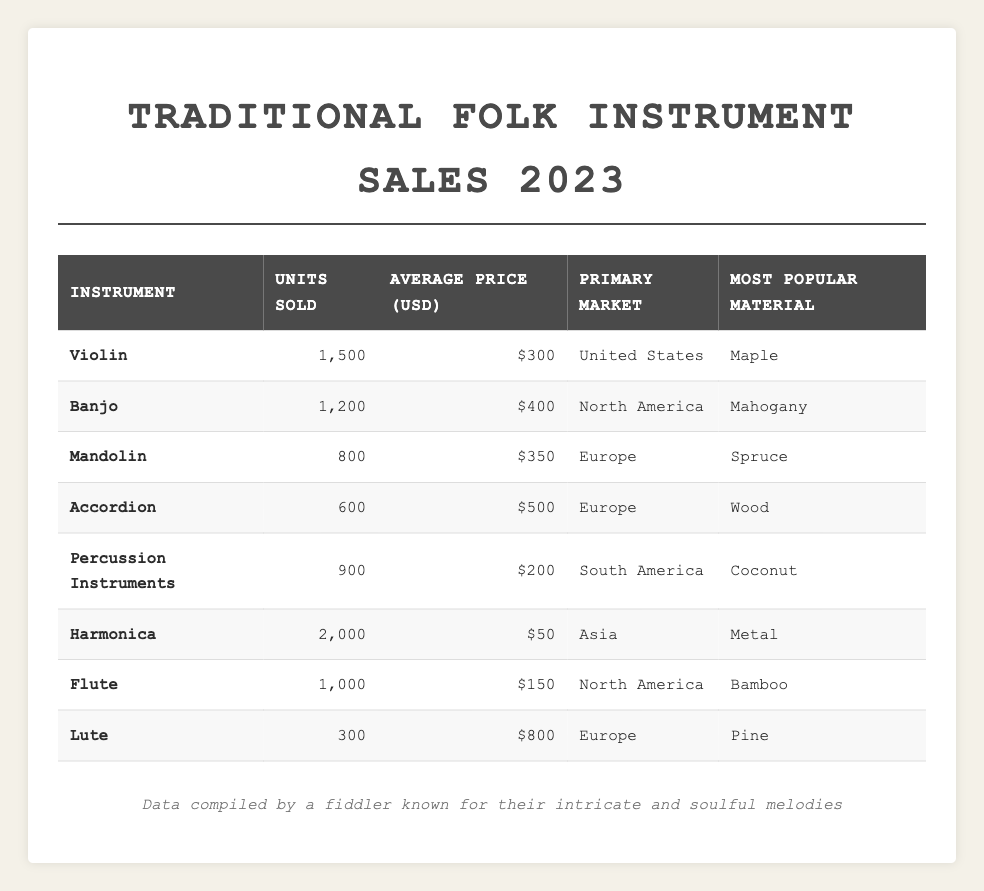What is the total number of units sold for all instruments? Add the units sold for each instrument: 1500 (Violin) + 1200 (Banjo) + 800 (Mandolin) + 600 (Accordion) + 900 (Percussion Instruments) + 2000 (Harmonica) + 1000 (Flute) + 300 (Lute) = 6300 units.
Answer: 6300 Which instrument has the highest average price? The average prices are as follows: Violin = $300, Banjo = $400, Mandolin = $350, Accordion = $500, Percussion Instruments = $200, Harmonica = $50, Flute = $150, Lute = $800. The Lute has the highest average price at $800.
Answer: Lute How many more units of Harmonica were sold compared to Accordion? Harmonica units sold = 2000, Accordion units sold = 600. The difference is 2000 - 600 = 1400 more units sold for Harmonica.
Answer: 1400 Is the primary market for Mandolin Europe? The primary market for Mandolin is listed as Europe in the table, so the statement is true.
Answer: Yes What is the average number of units sold for instruments sold in North America? There are two instruments: Banjo (1200) and Flute (1000). The total units sold = 1200 + 1000 = 2200. The average is 2200 / 2 = 1100 units.
Answer: 1100 Which material is most popular for instruments sold in the United States? According to the table, the Violin, which is sold in the United States, has Maple as its most popular material.
Answer: Maple If we remove the sales data for the Lute, what will be the new total number of units sold? Originally, the total units sold = 6300. The Lute sold 300 units, so the new total is 6300 - 300 = 6000 units.
Answer: 6000 What percentage of units sold does the Harmonica represent in total sales? Harmonica units sold = 2000, total units sold = 6300. The percentage is (2000 / 6300) * 100 = approximately 31.75%.
Answer: 31.75% How many instruments have an average price greater than $300? The instruments with average prices are Violin ($300), Banjo ($400), Mandolin ($350), Accordion ($500), Percussion Instruments ($200), Harmonica ($50), Flute ($150), Lute ($800). The ones above $300 are Banjo, Mandolin, Accordion, and Lute, which accounts for 4 instruments.
Answer: 4 What is the average price of instruments sold in Europe? The instruments sold in Europe are Mandolin ($350), Accordion ($500), and Lute ($800). The total average price is (350 + 500 + 800) / 3 = $550.
Answer: $550 